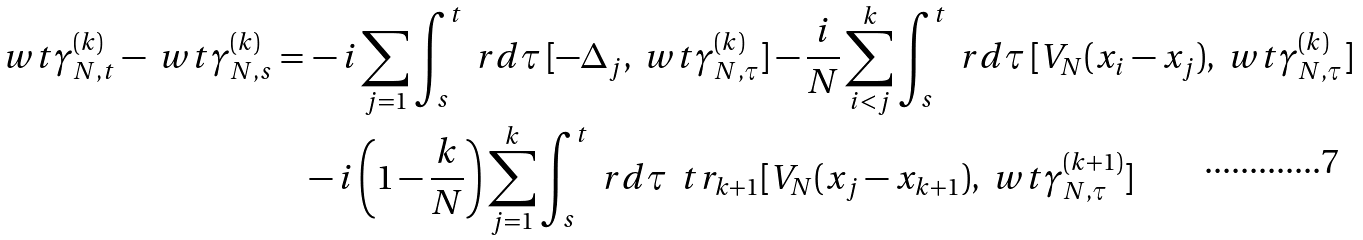Convert formula to latex. <formula><loc_0><loc_0><loc_500><loc_500>\ w t \gamma _ { N , t } ^ { ( k ) } - \ w t \gamma _ { N , s } ^ { ( k ) } = & \, - i \sum _ { j = 1 } \int _ { s } ^ { t } \ r d \tau \, [ - \Delta _ { j } , \ w t \gamma _ { N , \tau } ^ { ( k ) } ] - \frac { i } { N } \sum _ { i < j } ^ { k } \int _ { s } ^ { t } \ r d \tau \, [ V _ { N } ( x _ { i } - x _ { j } ) , \ w t \gamma _ { N , \tau } ^ { ( k ) } ] \\ & - i \left ( 1 - \frac { k } { N } \right ) \sum _ { j = 1 } ^ { k } \int _ { s } ^ { t } \ r d \tau \, \ t r _ { k + 1 } [ V _ { N } ( x _ { j } - x _ { k + 1 } ) , \ w t \gamma ^ { ( k + 1 ) } _ { N , \tau } ]</formula> 